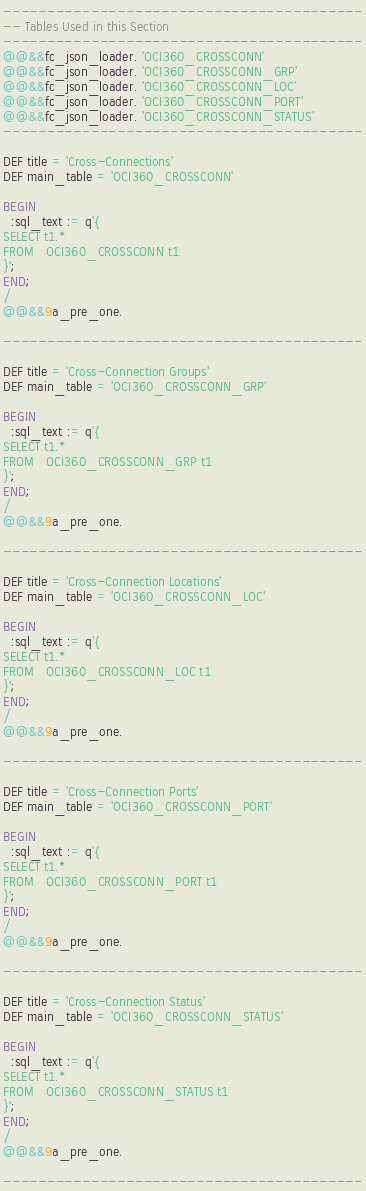Convert code to text. <code><loc_0><loc_0><loc_500><loc_500><_SQL_>-----------------------------------------
-- Tables Used in this Section
-----------------------------------------
@@&&fc_json_loader. 'OCI360_CROSSCONN'
@@&&fc_json_loader. 'OCI360_CROSSCONN_GRP'
@@&&fc_json_loader. 'OCI360_CROSSCONN_LOC'
@@&&fc_json_loader. 'OCI360_CROSSCONN_PORT'
@@&&fc_json_loader. 'OCI360_CROSSCONN_STATUS'
-----------------------------------------

DEF title = 'Cross-Connections'
DEF main_table = 'OCI360_CROSSCONN'

BEGIN
  :sql_text := q'{
SELECT t1.*
FROM   OCI360_CROSSCONN t1
}';
END;
/
@@&&9a_pre_one.

-----------------------------------------

DEF title = 'Cross-Connection Groups'
DEF main_table = 'OCI360_CROSSCONN_GRP'

BEGIN
  :sql_text := q'{
SELECT t1.*
FROM   OCI360_CROSSCONN_GRP t1
}';
END;
/
@@&&9a_pre_one.

-----------------------------------------

DEF title = 'Cross-Connection Locations'
DEF main_table = 'OCI360_CROSSCONN_LOC'

BEGIN
  :sql_text := q'{
SELECT t1.*
FROM   OCI360_CROSSCONN_LOC t1
}';
END;
/
@@&&9a_pre_one.

-----------------------------------------

DEF title = 'Cross-Connection Ports'
DEF main_table = 'OCI360_CROSSCONN_PORT'

BEGIN
  :sql_text := q'{
SELECT t1.*
FROM   OCI360_CROSSCONN_PORT t1
}';
END;
/
@@&&9a_pre_one.

-----------------------------------------

DEF title = 'Cross-Connection Status'
DEF main_table = 'OCI360_CROSSCONN_STATUS'

BEGIN
  :sql_text := q'{
SELECT t1.*
FROM   OCI360_CROSSCONN_STATUS t1
}';
END;
/
@@&&9a_pre_one.

-----------------------------------------</code> 